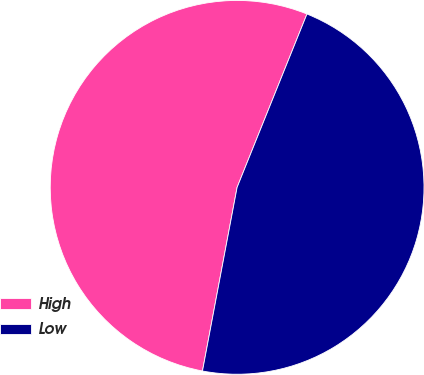<chart> <loc_0><loc_0><loc_500><loc_500><pie_chart><fcel>High<fcel>Low<nl><fcel>53.13%<fcel>46.87%<nl></chart> 